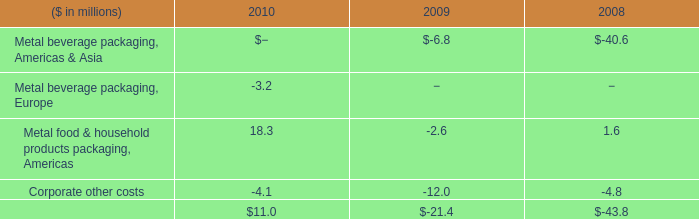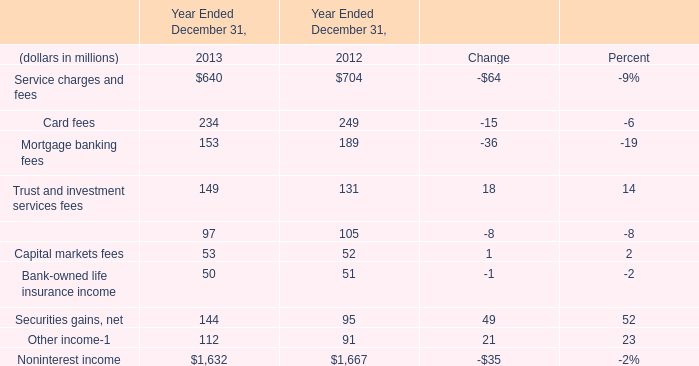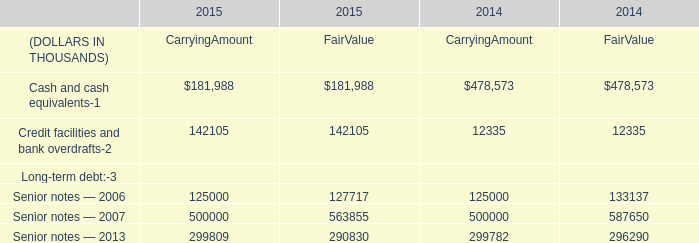What's the total amount of Total net (benefit) expense for pension plans of US plans in 2017? (in million) 
Computations: (((((3 + 533) - 865) + 2) + 173) + 6)
Answer: -148.0. 